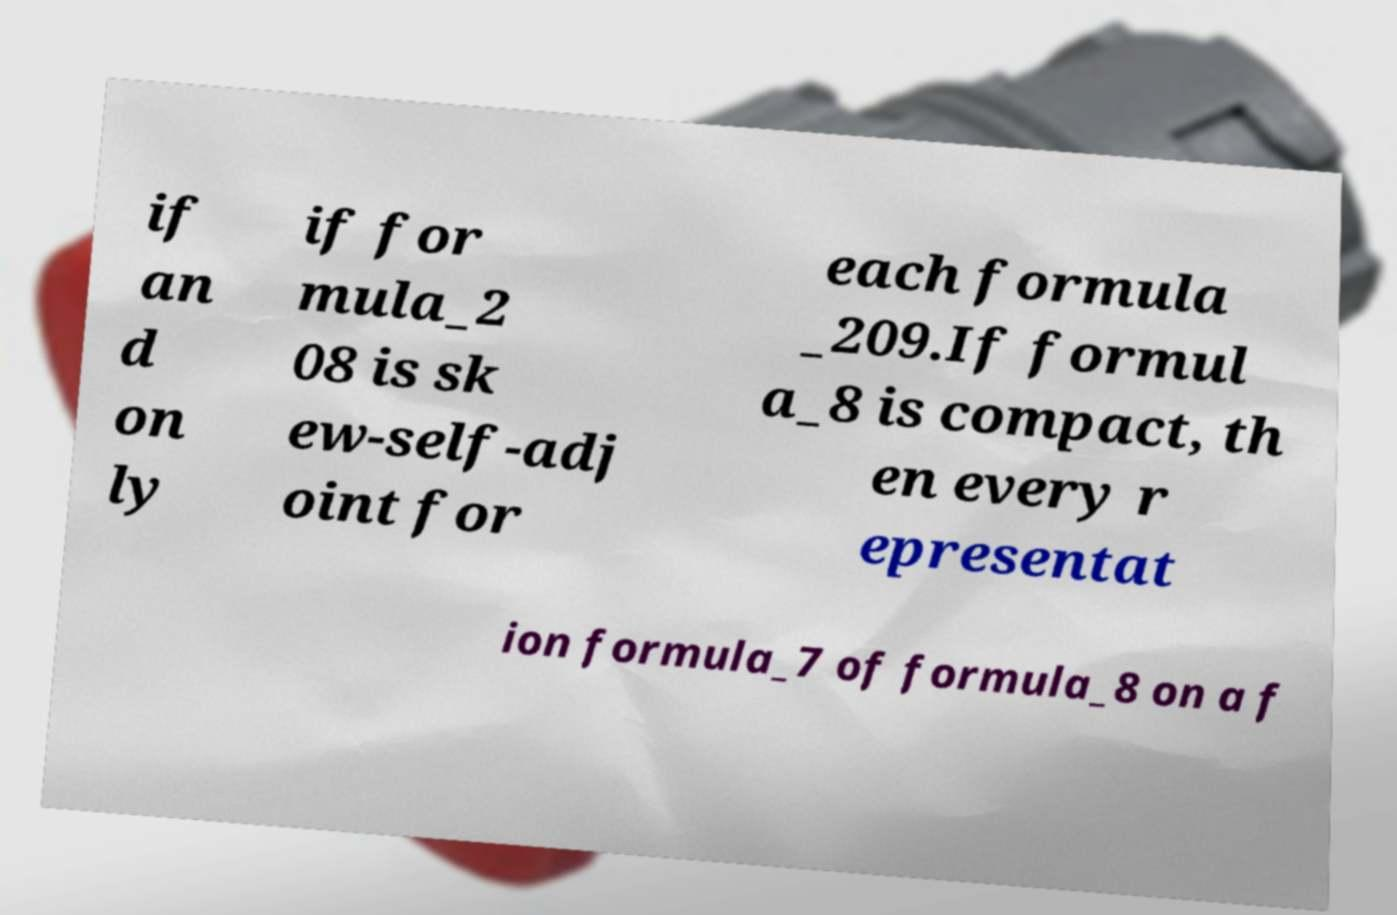Can you accurately transcribe the text from the provided image for me? if an d on ly if for mula_2 08 is sk ew-self-adj oint for each formula _209.If formul a_8 is compact, th en every r epresentat ion formula_7 of formula_8 on a f 